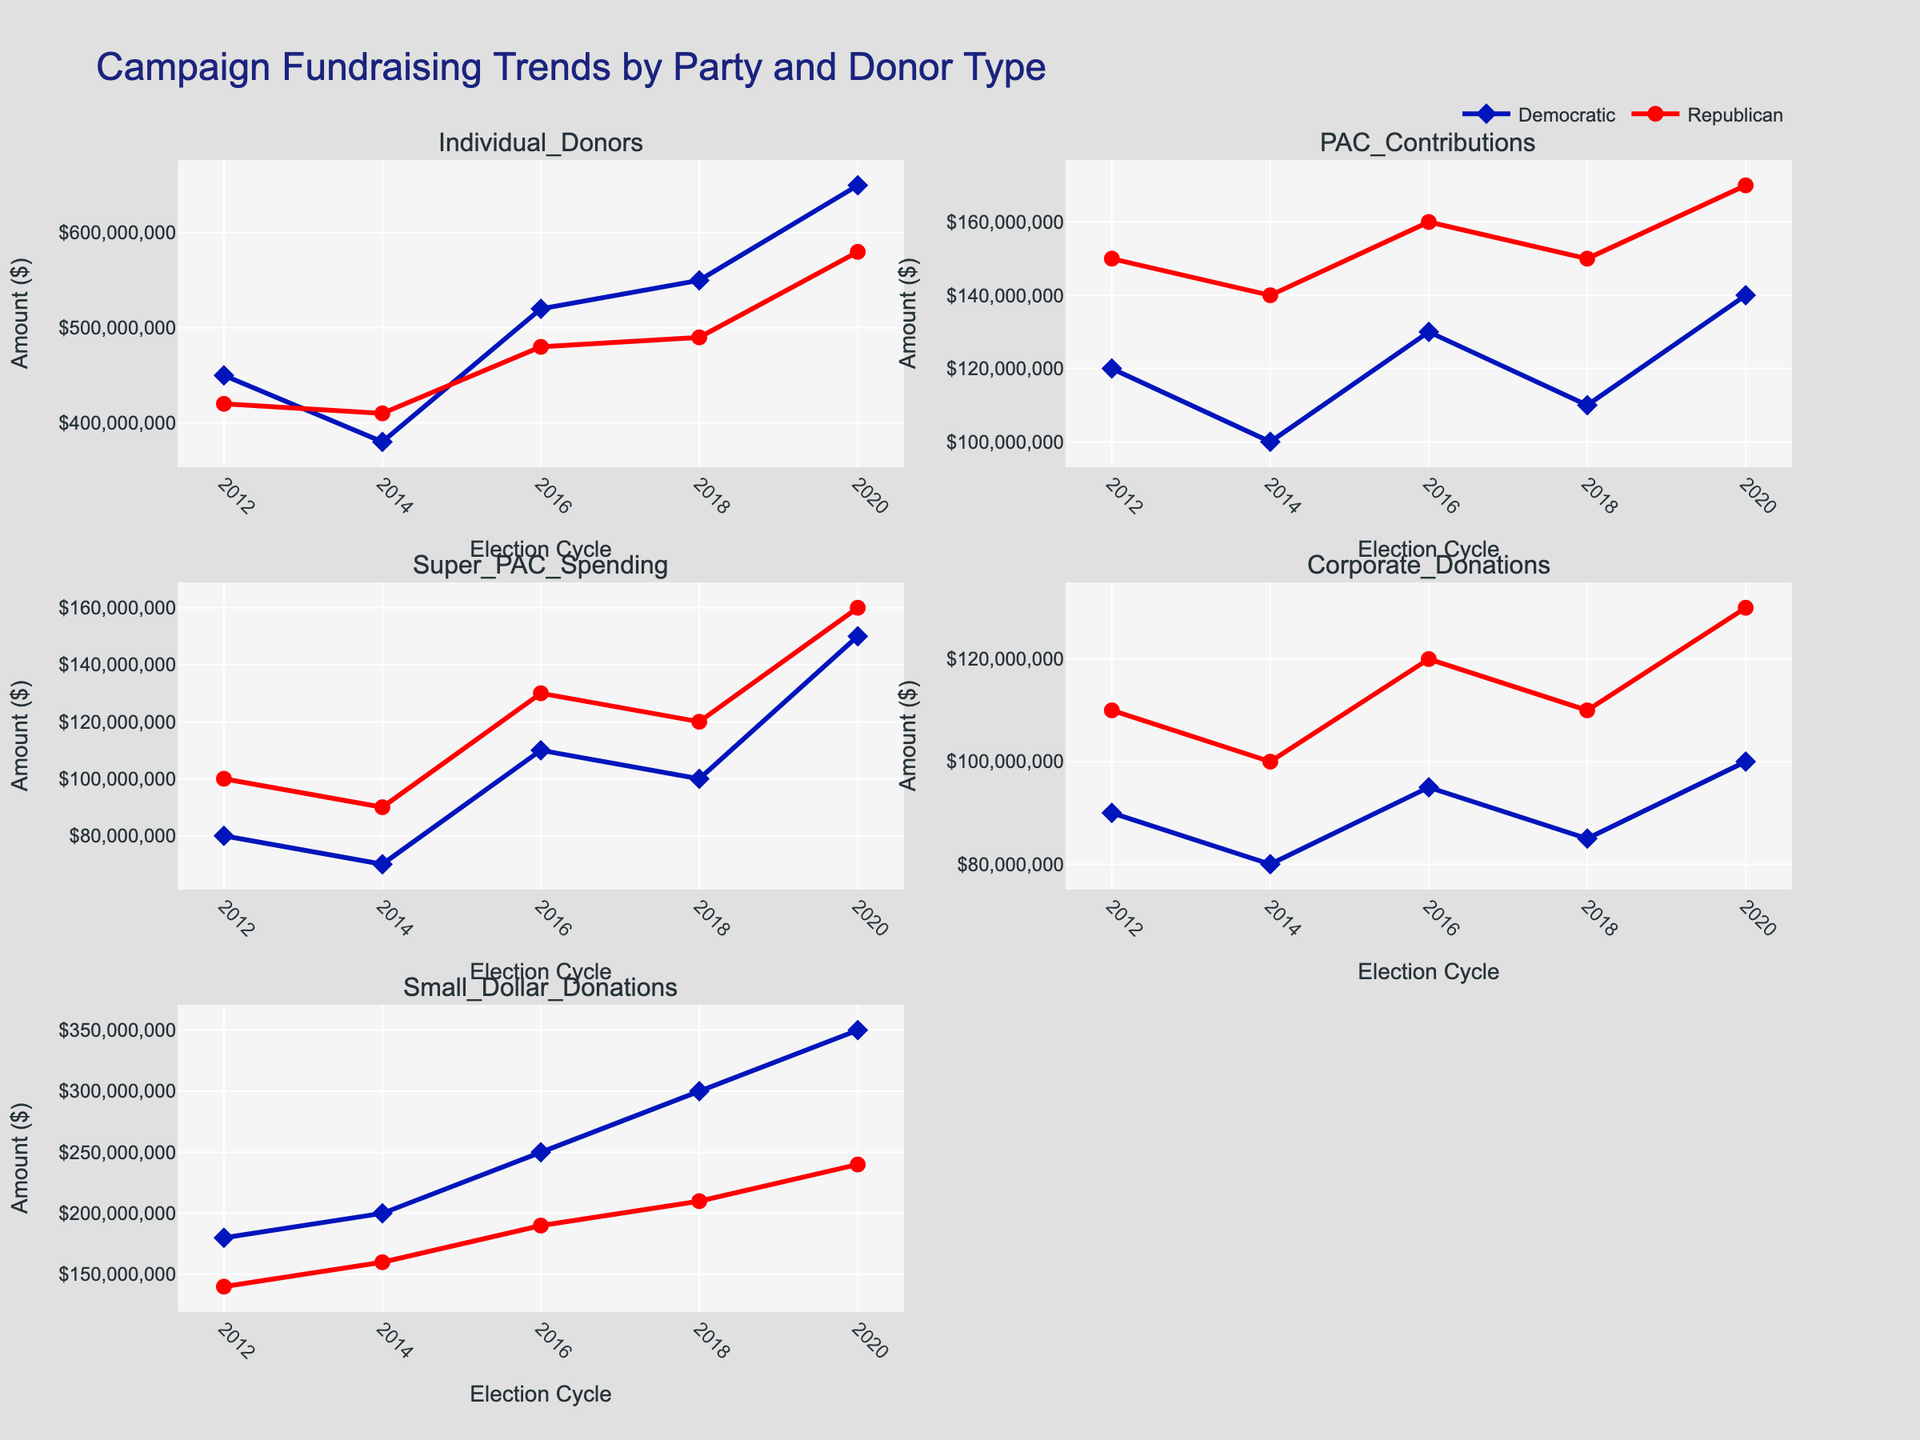What is the title of the figure? The title of the figure is displayed prominently at the top. It reads "Campaign Fundraising Trends by Party and Donor Type".
Answer: Campaign Fundraising Trends by Party and Donor Type How many donor types are displayed in the subplots? Each subplot has a title indicating the donor type it represents. Counting these titles will give the number of donor types. There are five subplot titles, hence five donor types.
Answer: Five Which party received more PAC Contributions in 2014? Locate the subplot with the title "PAC Contributions". Then, compare the lines for Democratic and Republican parties for the year 2014. The red line (Republican) is higher than the blue line (Democratic) for that year.
Answer: Republican What was the trend for Small Dollar Donations for the Democratic Party from 2016 to 2020? Find the subplot titled "Small Dollar Donations" and examine the blue line (Democratic) from 2016 to 2020. The line shows an increasing trend.
Answer: Increasing Which donor type showed the highest increase for the Democratic Party from 2012 to 2020? Observe each Democratic subplot line from 2012 to 2020 and determine the greatest difference in values. "Small Dollar Donations" shows the largest increase.
Answer: Small Dollar Donations How do the Super PAC Spending trends of Democrats and Republicans compare in 2016? Look at the "Super PAC Spending" subplot and compare the positions of the blue (Democratic) and red (Republican) lines in 2016. The red line is higher than the blue line.
Answer: Higher for Republicans What is the difference in Corporate Donations between the two parties in 2018? Locate the "Corporate Donations" subplot, then find the points for both parties in 2018. The Republicans received $110,000,000, and the Democrats received $85,000,000. The difference is $25,000,000.
Answer: $25,000,000 Which party consistently received more Individual Donors contributions from 2012 to 2020? Examine the "Individual Donors" subplot and compare the continuous trends of both party lines. The blue line (Democratic) is consistently higher than the red line (Republican).
Answer: Democratic What is the overall trend observed for PAC Contributions for both parties across all election cycles? Check the "PAC Contributions" subplot for trends. Both lines show fluctuations, but there is a general upward trend for both parties.
Answer: Upward trend Which party had higher overall fundraising from Small Dollar Donations in 2020, and by how much? In the "Small Dollar Donations" subplot, compare the points for both parties in 2020. Democrats received $350,000,000, and Republicans received $240,000,000. The difference is $110,000,000.
Answer: Democratic by $110,000,000 